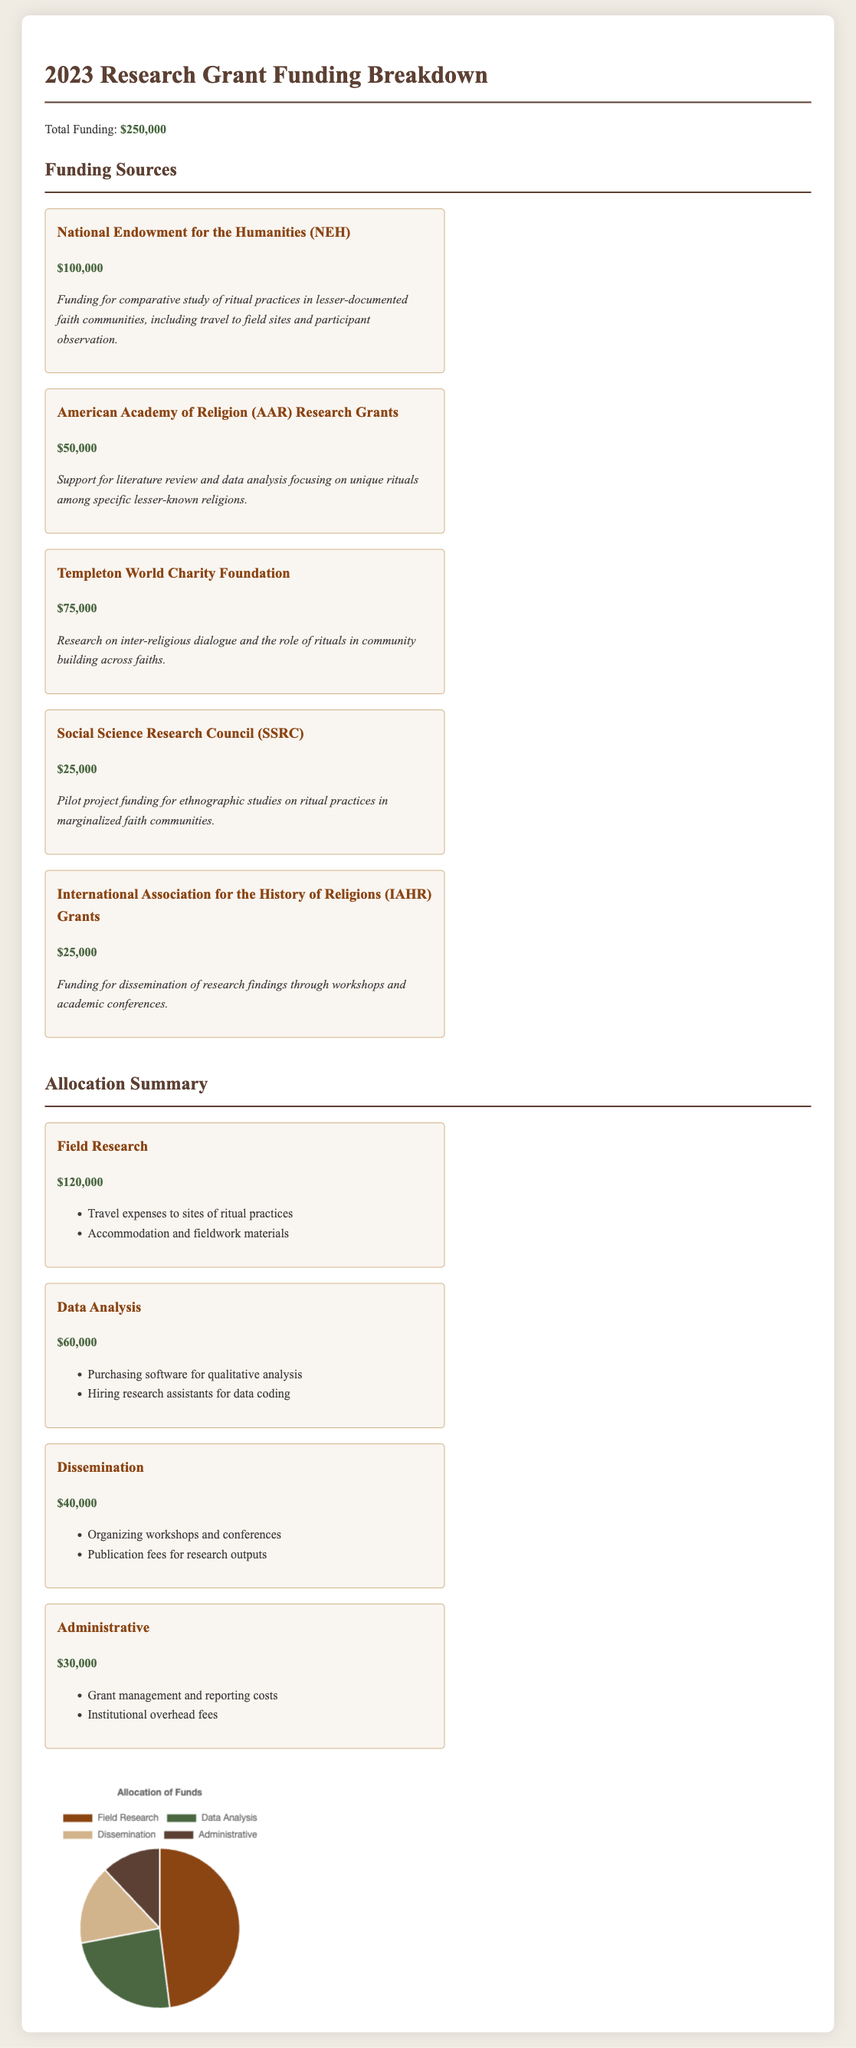What is the total funding for 2023? The total funding is explicitly stated in the document as $250,000.
Answer: $250,000 How much was received from the National Endowment for the Humanities? The document lists $100,000 as the amount received from the National Endowment for the Humanities.
Answer: $100,000 What is the purpose of the funding from the Templeton World Charity Foundation? The document describes the funding as for research on inter-religious dialogue and the role of rituals in community building.
Answer: Research on inter-religious dialogue and the role of rituals in community building Which funding source provided the least amount? The document indicates that the Social Science Research Council provided the least amount of funding at $25,000.
Answer: $25,000 What is allocated for field research? The document shows that $120,000 is allocated for field research purposes.
Answer: $120,000 How much is funded for dissemination activities? The funding allocated for dissemination activities is presented as $40,000 in the document.
Answer: $40,000 What is the total allocation for administrative costs? The total allocation for administrative costs is detailed in the document as $30,000.
Answer: $30,000 Which category received the highest amount of funding? The document states that field research received the highest funding amount at $120,000.
Answer: Field research How are the funds for Data Analysis intended to be used? The document lists the usage for Data Analysis funding as purchasing software for qualitative analysis and hiring research assistants.
Answer: Purchasing software for qualitative analysis and hiring research assistants What percentage of the total funding is allocated to field research? By comparing the amounts, field research receives $120,000 out of $250,000, which is 48%.
Answer: 48% 